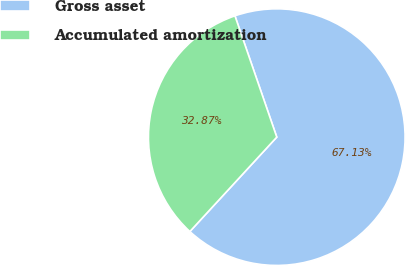<chart> <loc_0><loc_0><loc_500><loc_500><pie_chart><fcel>Gross asset<fcel>Accumulated amortization<nl><fcel>67.13%<fcel>32.87%<nl></chart> 